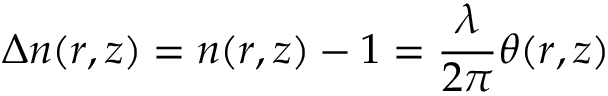Convert formula to latex. <formula><loc_0><loc_0><loc_500><loc_500>\Delta n ( r , z ) = n ( r , z ) - 1 = \frac { \lambda } { 2 \pi } \theta ( r , z )</formula> 